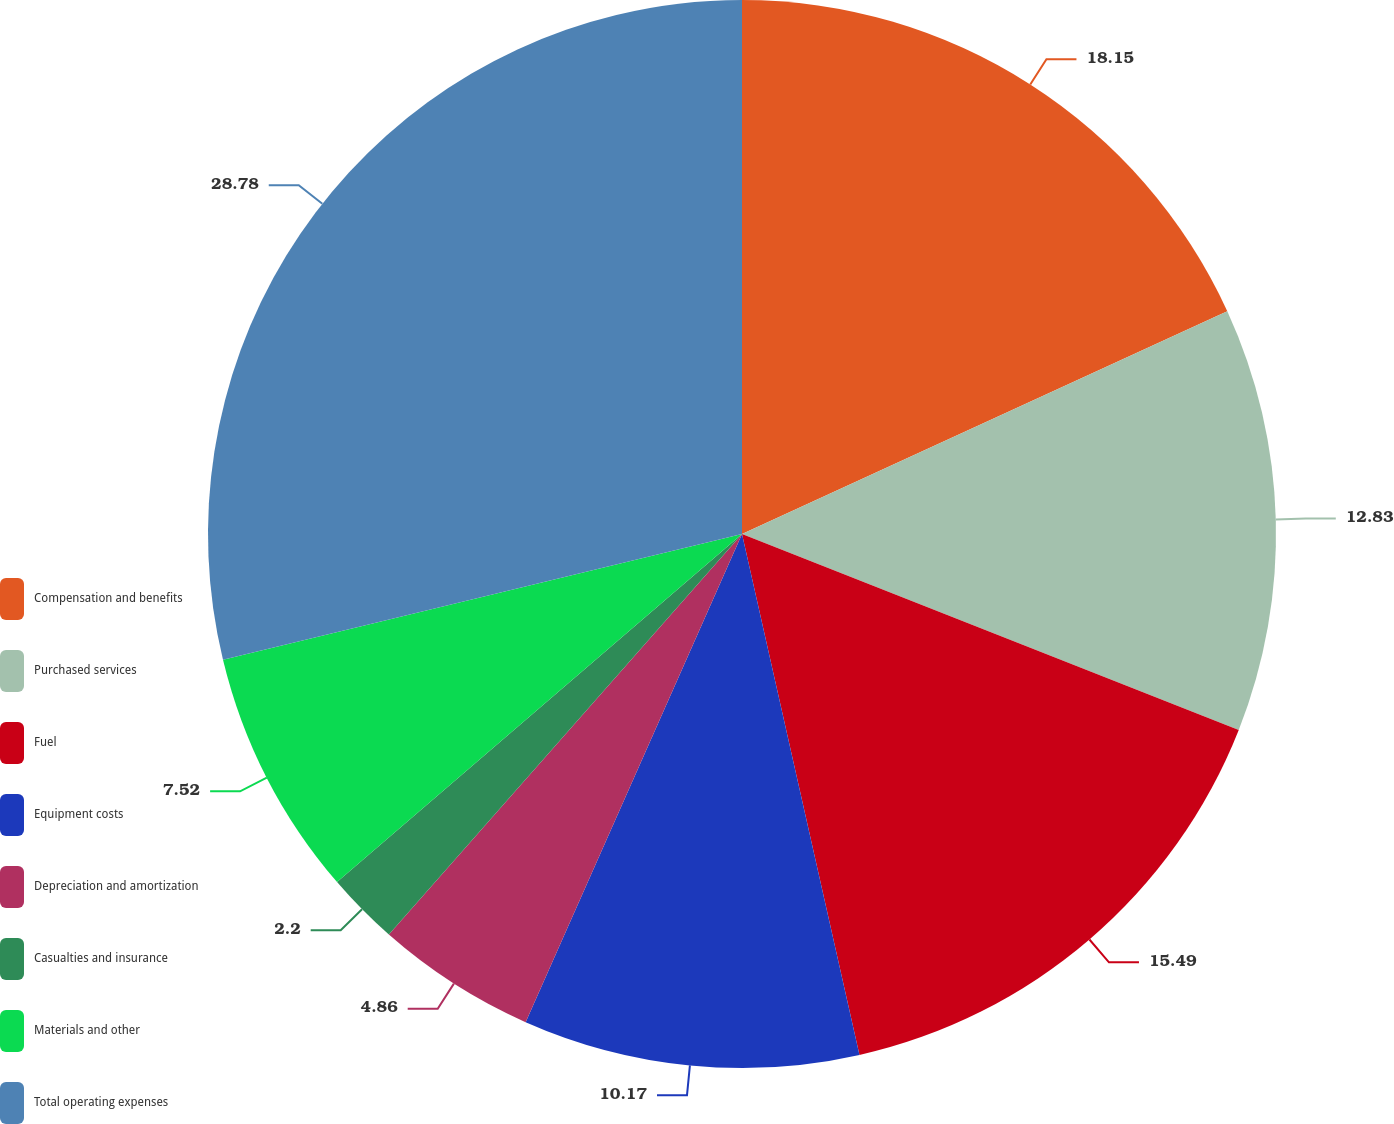Convert chart. <chart><loc_0><loc_0><loc_500><loc_500><pie_chart><fcel>Compensation and benefits<fcel>Purchased services<fcel>Fuel<fcel>Equipment costs<fcel>Depreciation and amortization<fcel>Casualties and insurance<fcel>Materials and other<fcel>Total operating expenses<nl><fcel>18.15%<fcel>12.83%<fcel>15.49%<fcel>10.17%<fcel>4.86%<fcel>2.2%<fcel>7.52%<fcel>28.78%<nl></chart> 